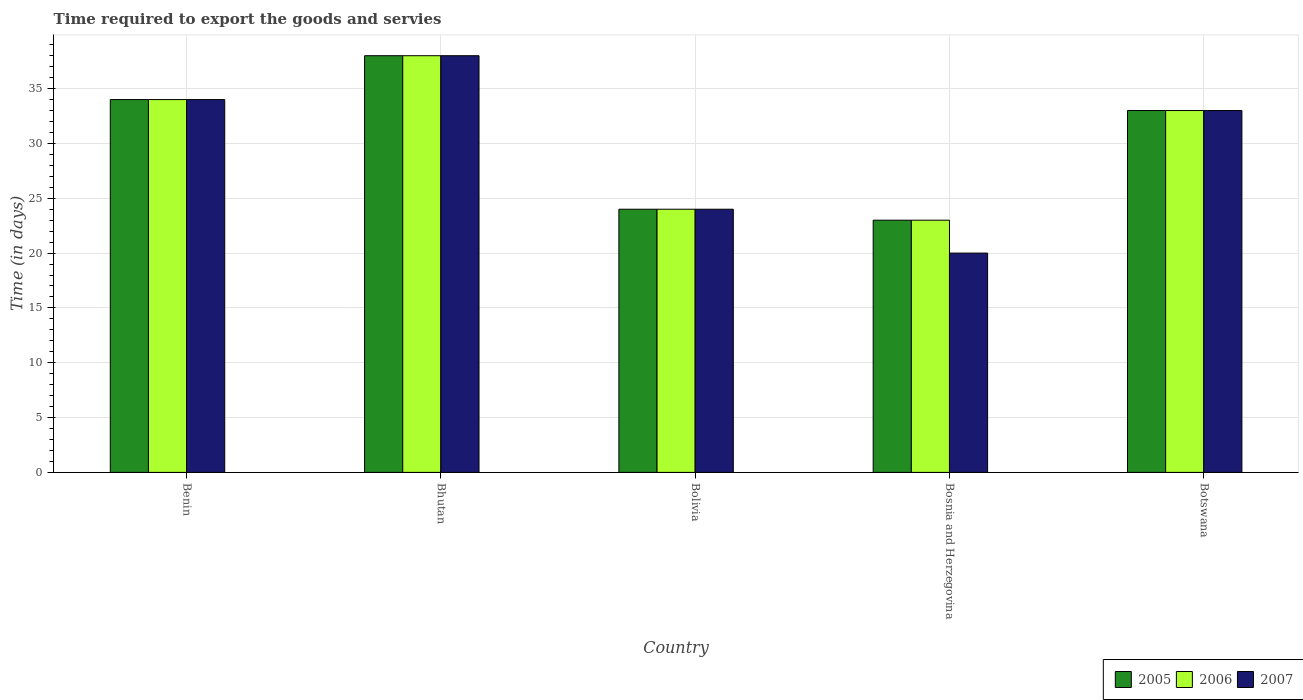How many different coloured bars are there?
Provide a short and direct response. 3. Are the number of bars per tick equal to the number of legend labels?
Your answer should be compact. Yes. Are the number of bars on each tick of the X-axis equal?
Provide a succinct answer. Yes. How many bars are there on the 4th tick from the left?
Offer a very short reply. 3. What is the label of the 5th group of bars from the left?
Provide a succinct answer. Botswana. Across all countries, what is the minimum number of days required to export the goods and services in 2006?
Give a very brief answer. 23. In which country was the number of days required to export the goods and services in 2007 maximum?
Your response must be concise. Bhutan. In which country was the number of days required to export the goods and services in 2007 minimum?
Offer a terse response. Bosnia and Herzegovina. What is the total number of days required to export the goods and services in 2006 in the graph?
Offer a terse response. 152. What is the difference between the number of days required to export the goods and services in 2007 in Benin and that in Botswana?
Your response must be concise. 1. What is the difference between the number of days required to export the goods and services in 2006 in Bolivia and the number of days required to export the goods and services in 2005 in Bosnia and Herzegovina?
Your answer should be compact. 1. What is the average number of days required to export the goods and services in 2006 per country?
Offer a very short reply. 30.4. What is the ratio of the number of days required to export the goods and services in 2007 in Bosnia and Herzegovina to that in Botswana?
Offer a very short reply. 0.61. Is the number of days required to export the goods and services in 2007 in Bolivia less than that in Bosnia and Herzegovina?
Your answer should be very brief. No. Is the difference between the number of days required to export the goods and services in 2007 in Bhutan and Bosnia and Herzegovina greater than the difference between the number of days required to export the goods and services in 2005 in Bhutan and Bosnia and Herzegovina?
Your answer should be very brief. Yes. What is the difference between the highest and the second highest number of days required to export the goods and services in 2006?
Provide a short and direct response. -1. In how many countries, is the number of days required to export the goods and services in 2007 greater than the average number of days required to export the goods and services in 2007 taken over all countries?
Ensure brevity in your answer.  3. Is it the case that in every country, the sum of the number of days required to export the goods and services in 2006 and number of days required to export the goods and services in 2005 is greater than the number of days required to export the goods and services in 2007?
Offer a very short reply. Yes. How many bars are there?
Keep it short and to the point. 15. How many countries are there in the graph?
Give a very brief answer. 5. How many legend labels are there?
Make the answer very short. 3. What is the title of the graph?
Your answer should be compact. Time required to export the goods and servies. What is the label or title of the X-axis?
Your answer should be compact. Country. What is the label or title of the Y-axis?
Your answer should be compact. Time (in days). What is the Time (in days) in 2007 in Bolivia?
Give a very brief answer. 24. What is the Time (in days) in 2005 in Bosnia and Herzegovina?
Your answer should be very brief. 23. What is the Time (in days) of 2007 in Bosnia and Herzegovina?
Keep it short and to the point. 20. What is the Time (in days) in 2005 in Botswana?
Provide a succinct answer. 33. What is the Time (in days) of 2006 in Botswana?
Provide a short and direct response. 33. What is the Time (in days) in 2007 in Botswana?
Keep it short and to the point. 33. Across all countries, what is the maximum Time (in days) of 2005?
Your response must be concise. 38. Across all countries, what is the maximum Time (in days) in 2007?
Offer a terse response. 38. What is the total Time (in days) in 2005 in the graph?
Provide a succinct answer. 152. What is the total Time (in days) of 2006 in the graph?
Your answer should be very brief. 152. What is the total Time (in days) in 2007 in the graph?
Offer a very short reply. 149. What is the difference between the Time (in days) in 2006 in Benin and that in Bhutan?
Your response must be concise. -4. What is the difference between the Time (in days) of 2005 in Benin and that in Bolivia?
Keep it short and to the point. 10. What is the difference between the Time (in days) of 2006 in Benin and that in Bolivia?
Keep it short and to the point. 10. What is the difference between the Time (in days) of 2007 in Benin and that in Bolivia?
Make the answer very short. 10. What is the difference between the Time (in days) in 2006 in Benin and that in Bosnia and Herzegovina?
Offer a very short reply. 11. What is the difference between the Time (in days) in 2007 in Benin and that in Bosnia and Herzegovina?
Your answer should be compact. 14. What is the difference between the Time (in days) of 2005 in Benin and that in Botswana?
Provide a succinct answer. 1. What is the difference between the Time (in days) of 2007 in Benin and that in Botswana?
Give a very brief answer. 1. What is the difference between the Time (in days) in 2005 in Bhutan and that in Bolivia?
Make the answer very short. 14. What is the difference between the Time (in days) of 2007 in Bhutan and that in Bolivia?
Your answer should be compact. 14. What is the difference between the Time (in days) in 2005 in Bhutan and that in Bosnia and Herzegovina?
Your answer should be very brief. 15. What is the difference between the Time (in days) of 2006 in Bhutan and that in Bosnia and Herzegovina?
Your answer should be very brief. 15. What is the difference between the Time (in days) of 2005 in Bhutan and that in Botswana?
Offer a terse response. 5. What is the difference between the Time (in days) in 2007 in Bhutan and that in Botswana?
Offer a very short reply. 5. What is the difference between the Time (in days) of 2005 in Bolivia and that in Bosnia and Herzegovina?
Your answer should be very brief. 1. What is the difference between the Time (in days) in 2007 in Bolivia and that in Bosnia and Herzegovina?
Your response must be concise. 4. What is the difference between the Time (in days) of 2005 in Benin and the Time (in days) of 2006 in Bhutan?
Ensure brevity in your answer.  -4. What is the difference between the Time (in days) in 2006 in Benin and the Time (in days) in 2007 in Bhutan?
Offer a very short reply. -4. What is the difference between the Time (in days) of 2005 in Benin and the Time (in days) of 2007 in Bolivia?
Your answer should be very brief. 10. What is the difference between the Time (in days) in 2006 in Benin and the Time (in days) in 2007 in Bolivia?
Your response must be concise. 10. What is the difference between the Time (in days) in 2005 in Benin and the Time (in days) in 2006 in Bosnia and Herzegovina?
Offer a very short reply. 11. What is the difference between the Time (in days) in 2005 in Benin and the Time (in days) in 2007 in Bosnia and Herzegovina?
Provide a short and direct response. 14. What is the difference between the Time (in days) in 2006 in Benin and the Time (in days) in 2007 in Bosnia and Herzegovina?
Your answer should be very brief. 14. What is the difference between the Time (in days) of 2005 in Benin and the Time (in days) of 2006 in Botswana?
Provide a succinct answer. 1. What is the difference between the Time (in days) of 2005 in Benin and the Time (in days) of 2007 in Botswana?
Keep it short and to the point. 1. What is the difference between the Time (in days) in 2006 in Benin and the Time (in days) in 2007 in Botswana?
Your answer should be very brief. 1. What is the difference between the Time (in days) of 2005 in Bhutan and the Time (in days) of 2006 in Bolivia?
Offer a terse response. 14. What is the difference between the Time (in days) in 2005 in Bhutan and the Time (in days) in 2007 in Bolivia?
Make the answer very short. 14. What is the difference between the Time (in days) in 2006 in Bhutan and the Time (in days) in 2007 in Bolivia?
Provide a succinct answer. 14. What is the difference between the Time (in days) in 2005 in Bhutan and the Time (in days) in 2006 in Bosnia and Herzegovina?
Offer a terse response. 15. What is the difference between the Time (in days) of 2005 in Bhutan and the Time (in days) of 2007 in Botswana?
Your answer should be very brief. 5. What is the difference between the Time (in days) in 2006 in Bhutan and the Time (in days) in 2007 in Botswana?
Offer a terse response. 5. What is the difference between the Time (in days) of 2005 in Bolivia and the Time (in days) of 2006 in Bosnia and Herzegovina?
Make the answer very short. 1. What is the difference between the Time (in days) of 2005 in Bolivia and the Time (in days) of 2007 in Bosnia and Herzegovina?
Keep it short and to the point. 4. What is the difference between the Time (in days) of 2006 in Bolivia and the Time (in days) of 2007 in Bosnia and Herzegovina?
Offer a very short reply. 4. What is the difference between the Time (in days) in 2006 in Bolivia and the Time (in days) in 2007 in Botswana?
Ensure brevity in your answer.  -9. What is the difference between the Time (in days) in 2005 in Bosnia and Herzegovina and the Time (in days) in 2006 in Botswana?
Your answer should be compact. -10. What is the difference between the Time (in days) in 2005 in Bosnia and Herzegovina and the Time (in days) in 2007 in Botswana?
Your answer should be compact. -10. What is the average Time (in days) in 2005 per country?
Keep it short and to the point. 30.4. What is the average Time (in days) in 2006 per country?
Keep it short and to the point. 30.4. What is the average Time (in days) of 2007 per country?
Your response must be concise. 29.8. What is the difference between the Time (in days) in 2005 and Time (in days) in 2006 in Benin?
Your answer should be compact. 0. What is the difference between the Time (in days) in 2005 and Time (in days) in 2007 in Benin?
Your answer should be very brief. 0. What is the difference between the Time (in days) of 2006 and Time (in days) of 2007 in Benin?
Offer a very short reply. 0. What is the difference between the Time (in days) of 2005 and Time (in days) of 2007 in Bhutan?
Your response must be concise. 0. What is the difference between the Time (in days) in 2006 and Time (in days) in 2007 in Bhutan?
Offer a terse response. 0. What is the difference between the Time (in days) in 2005 and Time (in days) in 2006 in Bolivia?
Your response must be concise. 0. What is the difference between the Time (in days) of 2005 and Time (in days) of 2007 in Bolivia?
Offer a very short reply. 0. What is the difference between the Time (in days) of 2006 and Time (in days) of 2007 in Bolivia?
Ensure brevity in your answer.  0. What is the difference between the Time (in days) in 2005 and Time (in days) in 2007 in Botswana?
Your answer should be compact. 0. What is the difference between the Time (in days) of 2006 and Time (in days) of 2007 in Botswana?
Keep it short and to the point. 0. What is the ratio of the Time (in days) in 2005 in Benin to that in Bhutan?
Keep it short and to the point. 0.89. What is the ratio of the Time (in days) in 2006 in Benin to that in Bhutan?
Ensure brevity in your answer.  0.89. What is the ratio of the Time (in days) in 2007 in Benin to that in Bhutan?
Offer a very short reply. 0.89. What is the ratio of the Time (in days) of 2005 in Benin to that in Bolivia?
Give a very brief answer. 1.42. What is the ratio of the Time (in days) in 2006 in Benin to that in Bolivia?
Give a very brief answer. 1.42. What is the ratio of the Time (in days) in 2007 in Benin to that in Bolivia?
Ensure brevity in your answer.  1.42. What is the ratio of the Time (in days) of 2005 in Benin to that in Bosnia and Herzegovina?
Your answer should be compact. 1.48. What is the ratio of the Time (in days) in 2006 in Benin to that in Bosnia and Herzegovina?
Make the answer very short. 1.48. What is the ratio of the Time (in days) in 2005 in Benin to that in Botswana?
Give a very brief answer. 1.03. What is the ratio of the Time (in days) of 2006 in Benin to that in Botswana?
Make the answer very short. 1.03. What is the ratio of the Time (in days) in 2007 in Benin to that in Botswana?
Your answer should be compact. 1.03. What is the ratio of the Time (in days) in 2005 in Bhutan to that in Bolivia?
Give a very brief answer. 1.58. What is the ratio of the Time (in days) of 2006 in Bhutan to that in Bolivia?
Provide a succinct answer. 1.58. What is the ratio of the Time (in days) in 2007 in Bhutan to that in Bolivia?
Give a very brief answer. 1.58. What is the ratio of the Time (in days) of 2005 in Bhutan to that in Bosnia and Herzegovina?
Offer a very short reply. 1.65. What is the ratio of the Time (in days) of 2006 in Bhutan to that in Bosnia and Herzegovina?
Offer a very short reply. 1.65. What is the ratio of the Time (in days) in 2007 in Bhutan to that in Bosnia and Herzegovina?
Your answer should be compact. 1.9. What is the ratio of the Time (in days) in 2005 in Bhutan to that in Botswana?
Provide a succinct answer. 1.15. What is the ratio of the Time (in days) in 2006 in Bhutan to that in Botswana?
Offer a very short reply. 1.15. What is the ratio of the Time (in days) in 2007 in Bhutan to that in Botswana?
Give a very brief answer. 1.15. What is the ratio of the Time (in days) in 2005 in Bolivia to that in Bosnia and Herzegovina?
Offer a very short reply. 1.04. What is the ratio of the Time (in days) in 2006 in Bolivia to that in Bosnia and Herzegovina?
Your response must be concise. 1.04. What is the ratio of the Time (in days) in 2007 in Bolivia to that in Bosnia and Herzegovina?
Your answer should be very brief. 1.2. What is the ratio of the Time (in days) of 2005 in Bolivia to that in Botswana?
Your answer should be very brief. 0.73. What is the ratio of the Time (in days) of 2006 in Bolivia to that in Botswana?
Provide a succinct answer. 0.73. What is the ratio of the Time (in days) in 2007 in Bolivia to that in Botswana?
Your response must be concise. 0.73. What is the ratio of the Time (in days) of 2005 in Bosnia and Herzegovina to that in Botswana?
Give a very brief answer. 0.7. What is the ratio of the Time (in days) of 2006 in Bosnia and Herzegovina to that in Botswana?
Offer a terse response. 0.7. What is the ratio of the Time (in days) of 2007 in Bosnia and Herzegovina to that in Botswana?
Your answer should be compact. 0.61. What is the difference between the highest and the second highest Time (in days) in 2005?
Provide a short and direct response. 4. What is the difference between the highest and the lowest Time (in days) in 2005?
Offer a very short reply. 15. 